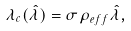<formula> <loc_0><loc_0><loc_500><loc_500>\lambda _ { c } ( \hat { \lambda } ) = \sigma \rho _ { e f f } \hat { \lambda } ,</formula> 